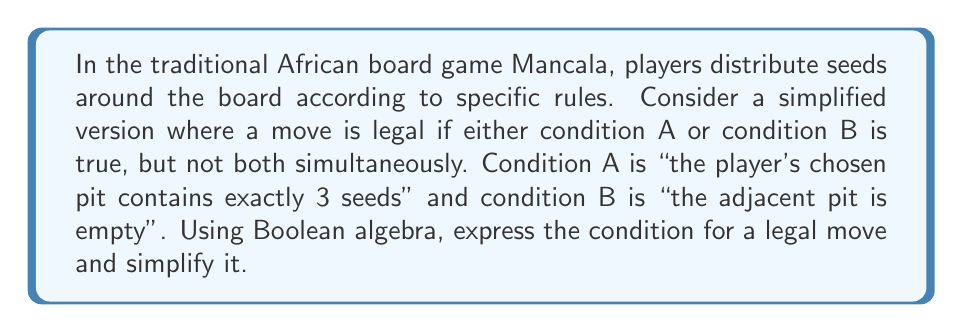Can you answer this question? Let's approach this step-by-step using Boolean algebra:

1) Let's define our variables:
   $A$ = "the player's chosen pit contains exactly 3 seeds"
   $B$ = "the adjacent pit is empty"

2) The condition for a legal move is that either A or B is true, but not both. This can be expressed as:

   $$(A \oplus B)$$

   Where $\oplus$ represents the exclusive OR (XOR) operation.

3) We can expand the XOR operation using basic Boolean operations:

   $$(A \oplus B) = (A \lor B) \land (\lnot(A \land B))$$

4) Using the distributive law, we can expand this further:

   $$(A \lor B) \land (\lnot A \lor \lnot B)$$

5) Now, let's apply the distributive law again:

   $$(A \land \lnot A) \lor (A \land \lnot B) \lor (B \land \lnot A) \lor (B \land \lnot B)$$

6) Simplify using the following Boolean algebra rules:
   - $A \land \lnot A = 0$ (always false)
   - $B \land \lnot B = 0$ (always false)

   This leaves us with:

   $$(A \land \lnot B) \lor (B \land \lnot A)$$

This final expression represents the simplified Boolean condition for a legal move in our simplified Mancala game.
Answer: $(A \land \lnot B) \lor (B \land \lnot A)$ 